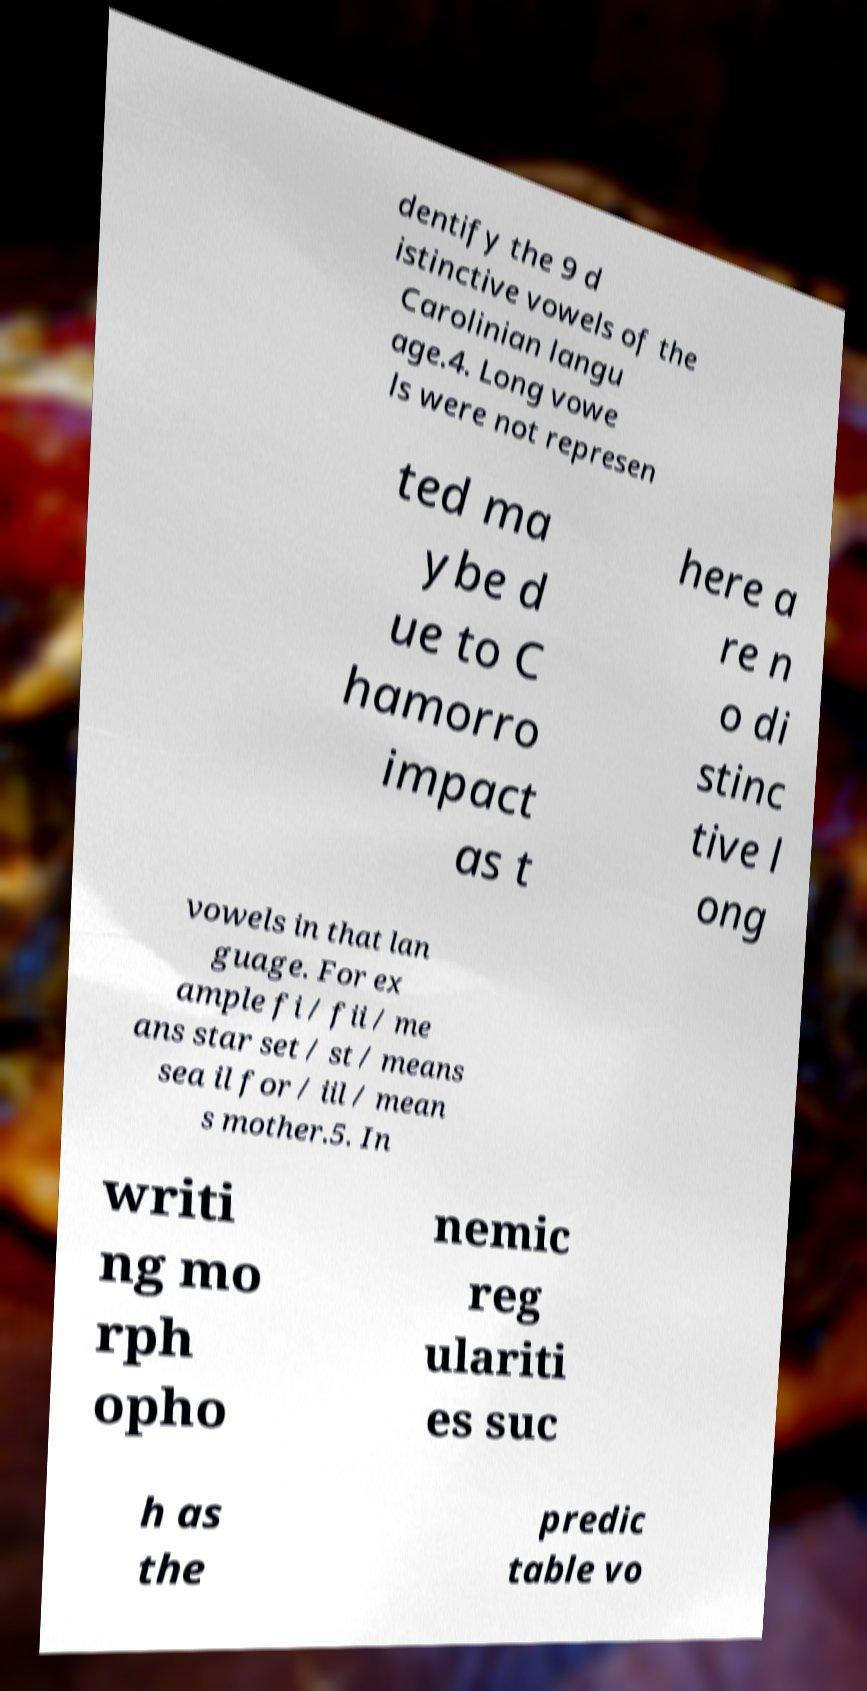There's text embedded in this image that I need extracted. Can you transcribe it verbatim? dentify the 9 d istinctive vowels of the Carolinian langu age.4. Long vowe ls were not represen ted ma ybe d ue to C hamorro impact as t here a re n o di stinc tive l ong vowels in that lan guage. For ex ample fi / fii / me ans star set / st / means sea il for / iil / mean s mother.5. In writi ng mo rph opho nemic reg ulariti es suc h as the predic table vo 